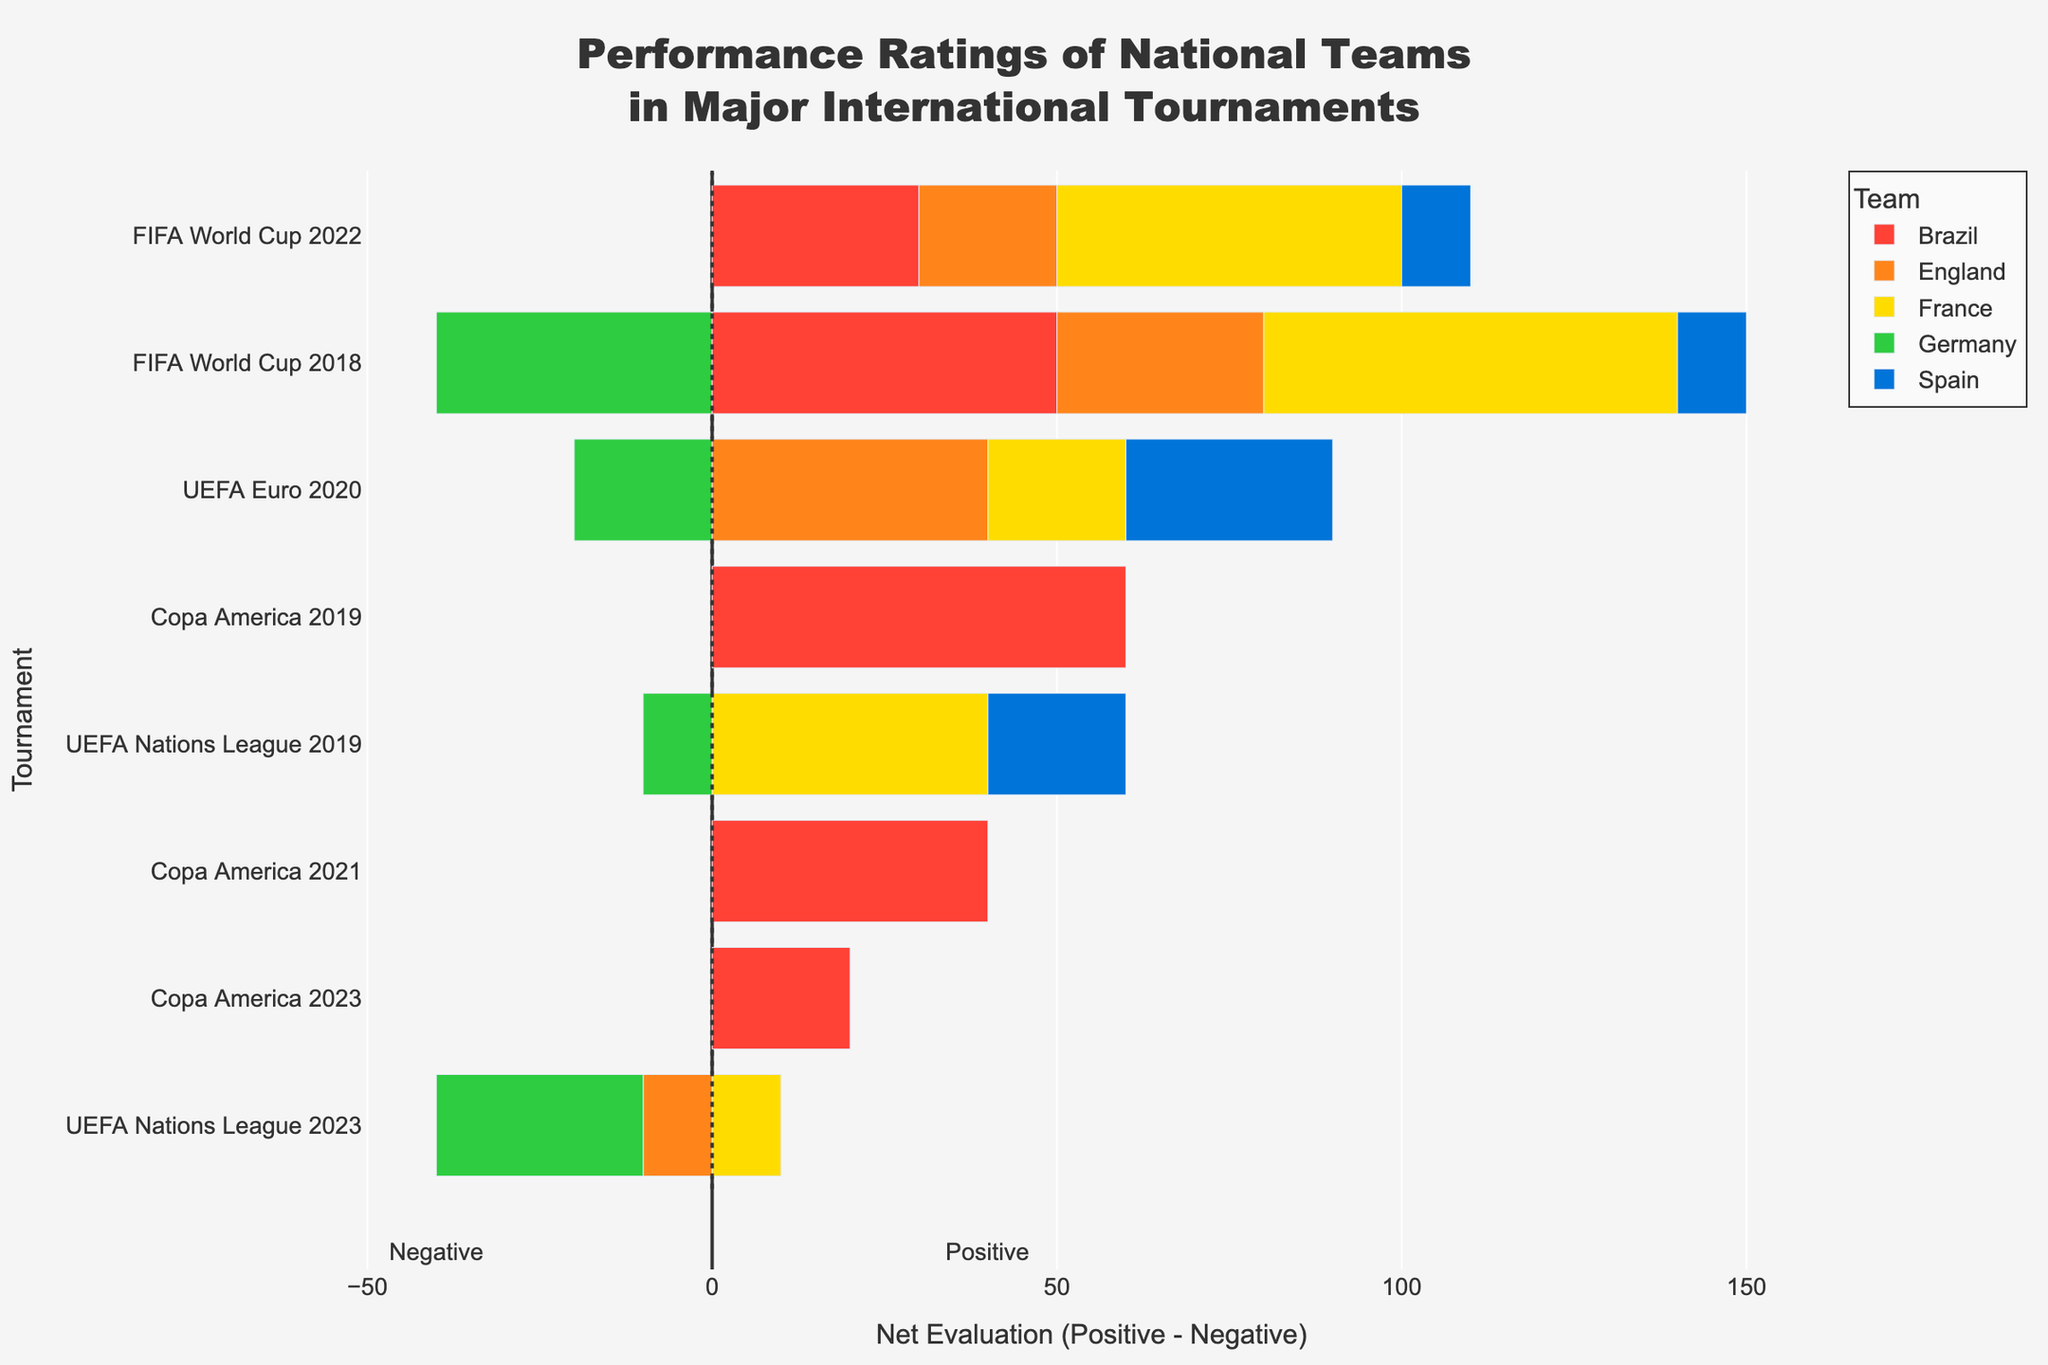Who had the highest positive evaluations in any of the tournaments? To determine the highest positive evaluations, scan through the positive evaluations of each team for the tournaments listed. France in the FIFA World Cup 2018 had 80 positive evaluations, which is the highest.
Answer: France in the FIFA World Cup 2018 What was the net evaluation of England in the UEFA Nations League 2023? Calculate the net evaluation by subtracting negative evaluations from positive evaluations for England in the UEFA Nations League 2023 (45 - 55 = -10).
Answer: -10 Which team had the most fluctuations in net evaluations across tournaments? By examining the net evaluations, we can see that England's net evaluations vary significantly from 30 at UEFA Euro 2020 to -10 at UEFA Nations League 2023, indicating high fluctuations.
Answer: England Compare the net evaluations of Brazil in FIFA World Cup 2018 and FIFA World Cup 2022. Which one is higher? Look at Brazil's net evaluation for FIFA World Cup 2018 (75-25=50) and FIFA World Cup 2022 (65-35=30). Since 50 is greater than 30, the net evaluation is higher in FIFA World Cup 2018.
Answer: FIFA World Cup 2018 How many tournaments did Germany have a negative net evaluation? Examine Germany's net evaluations: FIFA World Cup 2018 (-40), UEFA Euro 2020 (-20), UEFA Nations League 2019 (-10), FIFA World Cup 2022 (0), and UEFA Nations League 2023 (-30). Four of these are negative.
Answer: 4 Which team exhibited the worst net evaluation in any single tournament? By identifying the lowest net evaluation value among all, Germany in FIFA World Cup 2018 had the worst net evaluation at -40.
Answer: Germany in FIFA World Cup 2018 What is the average net evaluation of Spain across all tournaments? Calculate the net evaluations for Spain in all tournaments and find the average: (10+30+20+10+0)/5 = 70/5 = 14.
Answer: 14 Which team has the most positive rating trend over the five tournaments? France generally has higher positive ratings across the tournaments, but England's positive ratings show a general downward trend. Thus, France shows the most positive trend.
Answer: France Which tournament did France have the least positive evaluations? Examine France's positive evaluations in all tournaments and identify the lowest, which is UEFA Nations League 2023 with 55 positive evaluations.
Answer: UEFA Nations League 2023 In which tournament did Brazil have the closest net evaluation to zero? Evaluate Brazil's net evaluations across tournaments to find the one closest to zero: Copa America 2023 (60-40=20) is the closest to zero.
Answer: Copa America 2023 